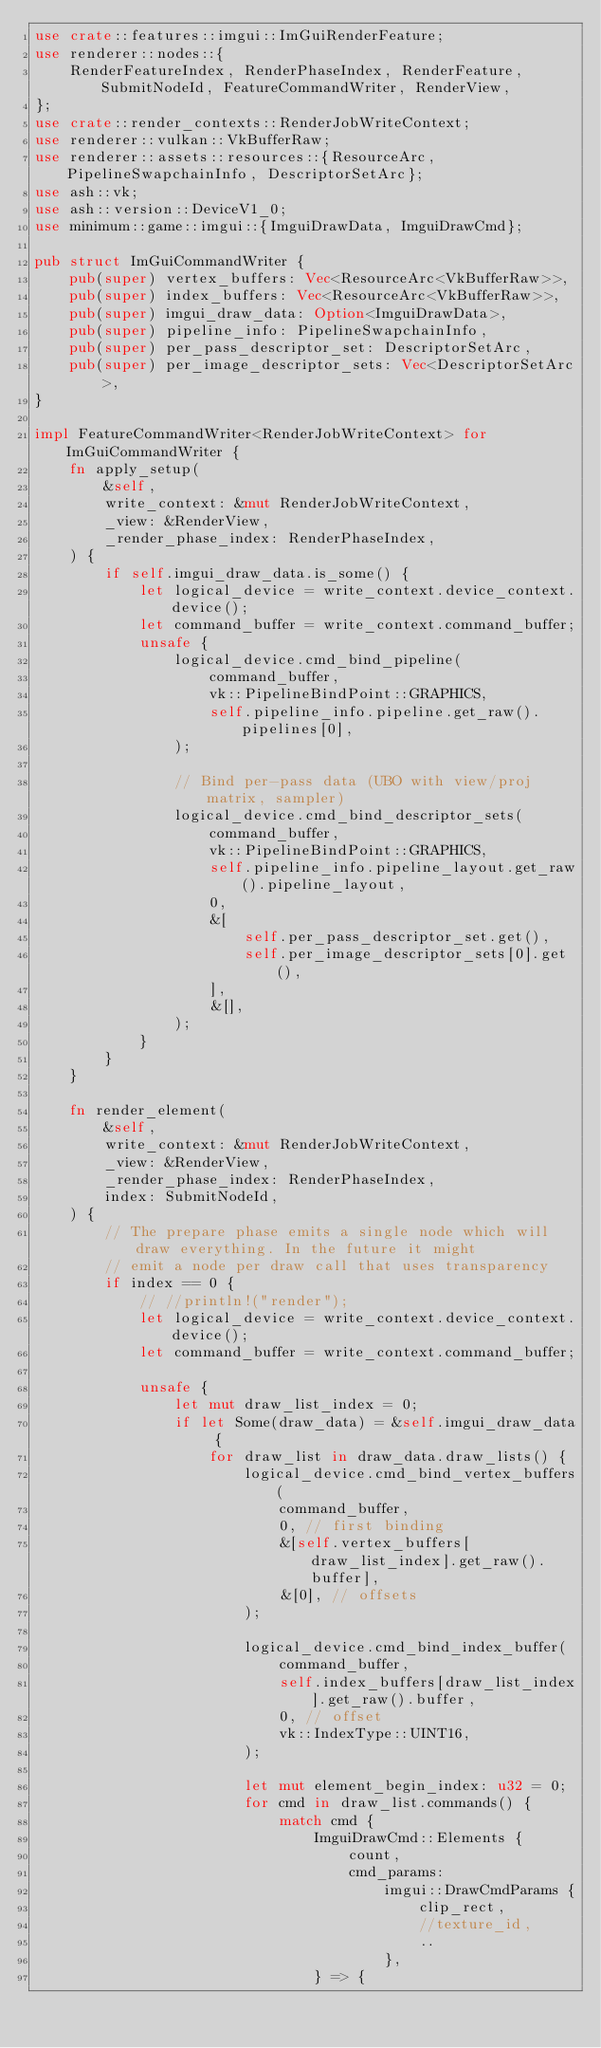<code> <loc_0><loc_0><loc_500><loc_500><_Rust_>use crate::features::imgui::ImGuiRenderFeature;
use renderer::nodes::{
    RenderFeatureIndex, RenderPhaseIndex, RenderFeature, SubmitNodeId, FeatureCommandWriter, RenderView,
};
use crate::render_contexts::RenderJobWriteContext;
use renderer::vulkan::VkBufferRaw;
use renderer::assets::resources::{ResourceArc, PipelineSwapchainInfo, DescriptorSetArc};
use ash::vk;
use ash::version::DeviceV1_0;
use minimum::game::imgui::{ImguiDrawData, ImguiDrawCmd};

pub struct ImGuiCommandWriter {
    pub(super) vertex_buffers: Vec<ResourceArc<VkBufferRaw>>,
    pub(super) index_buffers: Vec<ResourceArc<VkBufferRaw>>,
    pub(super) imgui_draw_data: Option<ImguiDrawData>,
    pub(super) pipeline_info: PipelineSwapchainInfo,
    pub(super) per_pass_descriptor_set: DescriptorSetArc,
    pub(super) per_image_descriptor_sets: Vec<DescriptorSetArc>,
}

impl FeatureCommandWriter<RenderJobWriteContext> for ImGuiCommandWriter {
    fn apply_setup(
        &self,
        write_context: &mut RenderJobWriteContext,
        _view: &RenderView,
        _render_phase_index: RenderPhaseIndex,
    ) {
        if self.imgui_draw_data.is_some() {
            let logical_device = write_context.device_context.device();
            let command_buffer = write_context.command_buffer;
            unsafe {
                logical_device.cmd_bind_pipeline(
                    command_buffer,
                    vk::PipelineBindPoint::GRAPHICS,
                    self.pipeline_info.pipeline.get_raw().pipelines[0],
                );

                // Bind per-pass data (UBO with view/proj matrix, sampler)
                logical_device.cmd_bind_descriptor_sets(
                    command_buffer,
                    vk::PipelineBindPoint::GRAPHICS,
                    self.pipeline_info.pipeline_layout.get_raw().pipeline_layout,
                    0,
                    &[
                        self.per_pass_descriptor_set.get(),
                        self.per_image_descriptor_sets[0].get(),
                    ],
                    &[],
                );
            }
        }
    }

    fn render_element(
        &self,
        write_context: &mut RenderJobWriteContext,
        _view: &RenderView,
        _render_phase_index: RenderPhaseIndex,
        index: SubmitNodeId,
    ) {
        // The prepare phase emits a single node which will draw everything. In the future it might
        // emit a node per draw call that uses transparency
        if index == 0 {
            // //println!("render");
            let logical_device = write_context.device_context.device();
            let command_buffer = write_context.command_buffer;

            unsafe {
                let mut draw_list_index = 0;
                if let Some(draw_data) = &self.imgui_draw_data {
                    for draw_list in draw_data.draw_lists() {
                        logical_device.cmd_bind_vertex_buffers(
                            command_buffer,
                            0, // first binding
                            &[self.vertex_buffers[draw_list_index].get_raw().buffer],
                            &[0], // offsets
                        );

                        logical_device.cmd_bind_index_buffer(
                            command_buffer,
                            self.index_buffers[draw_list_index].get_raw().buffer,
                            0, // offset
                            vk::IndexType::UINT16,
                        );

                        let mut element_begin_index: u32 = 0;
                        for cmd in draw_list.commands() {
                            match cmd {
                                ImguiDrawCmd::Elements {
                                    count,
                                    cmd_params:
                                        imgui::DrawCmdParams {
                                            clip_rect,
                                            //texture_id,
                                            ..
                                        },
                                } => {</code> 